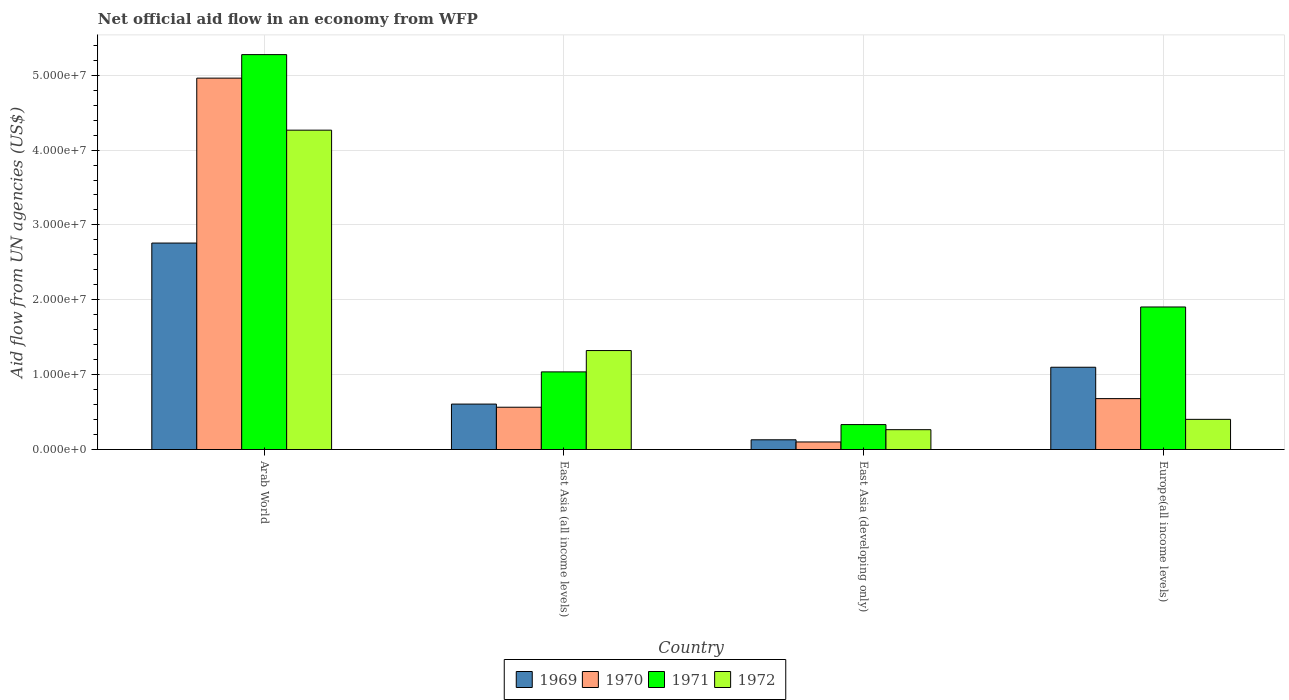How many bars are there on the 1st tick from the left?
Your answer should be compact. 4. What is the label of the 1st group of bars from the left?
Provide a succinct answer. Arab World. What is the net official aid flow in 1971 in East Asia (all income levels)?
Give a very brief answer. 1.04e+07. Across all countries, what is the maximum net official aid flow in 1970?
Ensure brevity in your answer.  4.96e+07. Across all countries, what is the minimum net official aid flow in 1971?
Provide a short and direct response. 3.33e+06. In which country was the net official aid flow in 1971 maximum?
Keep it short and to the point. Arab World. In which country was the net official aid flow in 1970 minimum?
Keep it short and to the point. East Asia (developing only). What is the total net official aid flow in 1971 in the graph?
Your answer should be compact. 8.55e+07. What is the difference between the net official aid flow in 1970 in East Asia (all income levels) and that in East Asia (developing only)?
Give a very brief answer. 4.64e+06. What is the difference between the net official aid flow in 1970 in East Asia (all income levels) and the net official aid flow in 1969 in Europe(all income levels)?
Your answer should be very brief. -5.34e+06. What is the average net official aid flow in 1970 per country?
Your response must be concise. 1.58e+07. What is the difference between the net official aid flow of/in 1972 and net official aid flow of/in 1971 in Arab World?
Provide a short and direct response. -1.01e+07. In how many countries, is the net official aid flow in 1971 greater than 50000000 US$?
Offer a very short reply. 1. What is the ratio of the net official aid flow in 1972 in Arab World to that in Europe(all income levels)?
Keep it short and to the point. 10.59. What is the difference between the highest and the second highest net official aid flow in 1969?
Ensure brevity in your answer.  2.15e+07. What is the difference between the highest and the lowest net official aid flow in 1971?
Offer a terse response. 4.94e+07. In how many countries, is the net official aid flow in 1969 greater than the average net official aid flow in 1969 taken over all countries?
Provide a succinct answer. 1. Is it the case that in every country, the sum of the net official aid flow in 1971 and net official aid flow in 1972 is greater than the net official aid flow in 1969?
Ensure brevity in your answer.  Yes. How many bars are there?
Offer a very short reply. 16. How many countries are there in the graph?
Keep it short and to the point. 4. Are the values on the major ticks of Y-axis written in scientific E-notation?
Your answer should be very brief. Yes. Where does the legend appear in the graph?
Offer a very short reply. Bottom center. How are the legend labels stacked?
Make the answer very short. Horizontal. What is the title of the graph?
Offer a very short reply. Net official aid flow in an economy from WFP. What is the label or title of the Y-axis?
Your response must be concise. Aid flow from UN agencies (US$). What is the Aid flow from UN agencies (US$) of 1969 in Arab World?
Your response must be concise. 2.76e+07. What is the Aid flow from UN agencies (US$) of 1970 in Arab World?
Provide a short and direct response. 4.96e+07. What is the Aid flow from UN agencies (US$) of 1971 in Arab World?
Give a very brief answer. 5.28e+07. What is the Aid flow from UN agencies (US$) of 1972 in Arab World?
Ensure brevity in your answer.  4.27e+07. What is the Aid flow from UN agencies (US$) of 1969 in East Asia (all income levels)?
Provide a short and direct response. 6.07e+06. What is the Aid flow from UN agencies (US$) of 1970 in East Asia (all income levels)?
Your answer should be very brief. 5.65e+06. What is the Aid flow from UN agencies (US$) of 1971 in East Asia (all income levels)?
Offer a very short reply. 1.04e+07. What is the Aid flow from UN agencies (US$) in 1972 in East Asia (all income levels)?
Your answer should be compact. 1.32e+07. What is the Aid flow from UN agencies (US$) in 1969 in East Asia (developing only)?
Offer a terse response. 1.30e+06. What is the Aid flow from UN agencies (US$) of 1970 in East Asia (developing only)?
Give a very brief answer. 1.01e+06. What is the Aid flow from UN agencies (US$) in 1971 in East Asia (developing only)?
Provide a short and direct response. 3.33e+06. What is the Aid flow from UN agencies (US$) in 1972 in East Asia (developing only)?
Keep it short and to the point. 2.65e+06. What is the Aid flow from UN agencies (US$) in 1969 in Europe(all income levels)?
Make the answer very short. 1.10e+07. What is the Aid flow from UN agencies (US$) in 1970 in Europe(all income levels)?
Give a very brief answer. 6.80e+06. What is the Aid flow from UN agencies (US$) of 1971 in Europe(all income levels)?
Your answer should be compact. 1.90e+07. What is the Aid flow from UN agencies (US$) in 1972 in Europe(all income levels)?
Keep it short and to the point. 4.03e+06. Across all countries, what is the maximum Aid flow from UN agencies (US$) in 1969?
Your answer should be very brief. 2.76e+07. Across all countries, what is the maximum Aid flow from UN agencies (US$) of 1970?
Ensure brevity in your answer.  4.96e+07. Across all countries, what is the maximum Aid flow from UN agencies (US$) of 1971?
Offer a very short reply. 5.28e+07. Across all countries, what is the maximum Aid flow from UN agencies (US$) of 1972?
Ensure brevity in your answer.  4.27e+07. Across all countries, what is the minimum Aid flow from UN agencies (US$) in 1969?
Provide a short and direct response. 1.30e+06. Across all countries, what is the minimum Aid flow from UN agencies (US$) in 1970?
Make the answer very short. 1.01e+06. Across all countries, what is the minimum Aid flow from UN agencies (US$) in 1971?
Your answer should be compact. 3.33e+06. Across all countries, what is the minimum Aid flow from UN agencies (US$) in 1972?
Make the answer very short. 2.65e+06. What is the total Aid flow from UN agencies (US$) of 1969 in the graph?
Offer a terse response. 4.59e+07. What is the total Aid flow from UN agencies (US$) of 1970 in the graph?
Offer a very short reply. 6.31e+07. What is the total Aid flow from UN agencies (US$) in 1971 in the graph?
Make the answer very short. 8.55e+07. What is the total Aid flow from UN agencies (US$) in 1972 in the graph?
Ensure brevity in your answer.  6.26e+07. What is the difference between the Aid flow from UN agencies (US$) of 1969 in Arab World and that in East Asia (all income levels)?
Ensure brevity in your answer.  2.15e+07. What is the difference between the Aid flow from UN agencies (US$) in 1970 in Arab World and that in East Asia (all income levels)?
Your response must be concise. 4.40e+07. What is the difference between the Aid flow from UN agencies (US$) in 1971 in Arab World and that in East Asia (all income levels)?
Offer a terse response. 4.24e+07. What is the difference between the Aid flow from UN agencies (US$) of 1972 in Arab World and that in East Asia (all income levels)?
Offer a very short reply. 2.94e+07. What is the difference between the Aid flow from UN agencies (US$) of 1969 in Arab World and that in East Asia (developing only)?
Offer a very short reply. 2.63e+07. What is the difference between the Aid flow from UN agencies (US$) in 1970 in Arab World and that in East Asia (developing only)?
Your answer should be compact. 4.86e+07. What is the difference between the Aid flow from UN agencies (US$) of 1971 in Arab World and that in East Asia (developing only)?
Give a very brief answer. 4.94e+07. What is the difference between the Aid flow from UN agencies (US$) in 1972 in Arab World and that in East Asia (developing only)?
Your answer should be very brief. 4.00e+07. What is the difference between the Aid flow from UN agencies (US$) in 1969 in Arab World and that in Europe(all income levels)?
Your response must be concise. 1.66e+07. What is the difference between the Aid flow from UN agencies (US$) of 1970 in Arab World and that in Europe(all income levels)?
Offer a very short reply. 4.28e+07. What is the difference between the Aid flow from UN agencies (US$) of 1971 in Arab World and that in Europe(all income levels)?
Your response must be concise. 3.37e+07. What is the difference between the Aid flow from UN agencies (US$) of 1972 in Arab World and that in Europe(all income levels)?
Your answer should be compact. 3.86e+07. What is the difference between the Aid flow from UN agencies (US$) in 1969 in East Asia (all income levels) and that in East Asia (developing only)?
Make the answer very short. 4.77e+06. What is the difference between the Aid flow from UN agencies (US$) of 1970 in East Asia (all income levels) and that in East Asia (developing only)?
Give a very brief answer. 4.64e+06. What is the difference between the Aid flow from UN agencies (US$) in 1971 in East Asia (all income levels) and that in East Asia (developing only)?
Keep it short and to the point. 7.04e+06. What is the difference between the Aid flow from UN agencies (US$) of 1972 in East Asia (all income levels) and that in East Asia (developing only)?
Provide a succinct answer. 1.06e+07. What is the difference between the Aid flow from UN agencies (US$) in 1969 in East Asia (all income levels) and that in Europe(all income levels)?
Your response must be concise. -4.92e+06. What is the difference between the Aid flow from UN agencies (US$) of 1970 in East Asia (all income levels) and that in Europe(all income levels)?
Offer a very short reply. -1.15e+06. What is the difference between the Aid flow from UN agencies (US$) of 1971 in East Asia (all income levels) and that in Europe(all income levels)?
Provide a short and direct response. -8.67e+06. What is the difference between the Aid flow from UN agencies (US$) in 1972 in East Asia (all income levels) and that in Europe(all income levels)?
Give a very brief answer. 9.19e+06. What is the difference between the Aid flow from UN agencies (US$) of 1969 in East Asia (developing only) and that in Europe(all income levels)?
Offer a very short reply. -9.69e+06. What is the difference between the Aid flow from UN agencies (US$) in 1970 in East Asia (developing only) and that in Europe(all income levels)?
Provide a succinct answer. -5.79e+06. What is the difference between the Aid flow from UN agencies (US$) in 1971 in East Asia (developing only) and that in Europe(all income levels)?
Provide a short and direct response. -1.57e+07. What is the difference between the Aid flow from UN agencies (US$) of 1972 in East Asia (developing only) and that in Europe(all income levels)?
Your answer should be very brief. -1.38e+06. What is the difference between the Aid flow from UN agencies (US$) of 1969 in Arab World and the Aid flow from UN agencies (US$) of 1970 in East Asia (all income levels)?
Keep it short and to the point. 2.19e+07. What is the difference between the Aid flow from UN agencies (US$) of 1969 in Arab World and the Aid flow from UN agencies (US$) of 1971 in East Asia (all income levels)?
Offer a very short reply. 1.72e+07. What is the difference between the Aid flow from UN agencies (US$) of 1969 in Arab World and the Aid flow from UN agencies (US$) of 1972 in East Asia (all income levels)?
Provide a succinct answer. 1.44e+07. What is the difference between the Aid flow from UN agencies (US$) of 1970 in Arab World and the Aid flow from UN agencies (US$) of 1971 in East Asia (all income levels)?
Your answer should be compact. 3.92e+07. What is the difference between the Aid flow from UN agencies (US$) in 1970 in Arab World and the Aid flow from UN agencies (US$) in 1972 in East Asia (all income levels)?
Keep it short and to the point. 3.64e+07. What is the difference between the Aid flow from UN agencies (US$) in 1971 in Arab World and the Aid flow from UN agencies (US$) in 1972 in East Asia (all income levels)?
Ensure brevity in your answer.  3.95e+07. What is the difference between the Aid flow from UN agencies (US$) in 1969 in Arab World and the Aid flow from UN agencies (US$) in 1970 in East Asia (developing only)?
Make the answer very short. 2.66e+07. What is the difference between the Aid flow from UN agencies (US$) in 1969 in Arab World and the Aid flow from UN agencies (US$) in 1971 in East Asia (developing only)?
Your response must be concise. 2.42e+07. What is the difference between the Aid flow from UN agencies (US$) in 1969 in Arab World and the Aid flow from UN agencies (US$) in 1972 in East Asia (developing only)?
Ensure brevity in your answer.  2.49e+07. What is the difference between the Aid flow from UN agencies (US$) in 1970 in Arab World and the Aid flow from UN agencies (US$) in 1971 in East Asia (developing only)?
Offer a very short reply. 4.63e+07. What is the difference between the Aid flow from UN agencies (US$) of 1970 in Arab World and the Aid flow from UN agencies (US$) of 1972 in East Asia (developing only)?
Ensure brevity in your answer.  4.70e+07. What is the difference between the Aid flow from UN agencies (US$) of 1971 in Arab World and the Aid flow from UN agencies (US$) of 1972 in East Asia (developing only)?
Offer a very short reply. 5.01e+07. What is the difference between the Aid flow from UN agencies (US$) in 1969 in Arab World and the Aid flow from UN agencies (US$) in 1970 in Europe(all income levels)?
Keep it short and to the point. 2.08e+07. What is the difference between the Aid flow from UN agencies (US$) in 1969 in Arab World and the Aid flow from UN agencies (US$) in 1971 in Europe(all income levels)?
Make the answer very short. 8.54e+06. What is the difference between the Aid flow from UN agencies (US$) in 1969 in Arab World and the Aid flow from UN agencies (US$) in 1972 in Europe(all income levels)?
Provide a short and direct response. 2.36e+07. What is the difference between the Aid flow from UN agencies (US$) of 1970 in Arab World and the Aid flow from UN agencies (US$) of 1971 in Europe(all income levels)?
Provide a succinct answer. 3.06e+07. What is the difference between the Aid flow from UN agencies (US$) of 1970 in Arab World and the Aid flow from UN agencies (US$) of 1972 in Europe(all income levels)?
Make the answer very short. 4.56e+07. What is the difference between the Aid flow from UN agencies (US$) of 1971 in Arab World and the Aid flow from UN agencies (US$) of 1972 in Europe(all income levels)?
Keep it short and to the point. 4.87e+07. What is the difference between the Aid flow from UN agencies (US$) in 1969 in East Asia (all income levels) and the Aid flow from UN agencies (US$) in 1970 in East Asia (developing only)?
Provide a succinct answer. 5.06e+06. What is the difference between the Aid flow from UN agencies (US$) of 1969 in East Asia (all income levels) and the Aid flow from UN agencies (US$) of 1971 in East Asia (developing only)?
Offer a terse response. 2.74e+06. What is the difference between the Aid flow from UN agencies (US$) of 1969 in East Asia (all income levels) and the Aid flow from UN agencies (US$) of 1972 in East Asia (developing only)?
Keep it short and to the point. 3.42e+06. What is the difference between the Aid flow from UN agencies (US$) of 1970 in East Asia (all income levels) and the Aid flow from UN agencies (US$) of 1971 in East Asia (developing only)?
Provide a succinct answer. 2.32e+06. What is the difference between the Aid flow from UN agencies (US$) of 1970 in East Asia (all income levels) and the Aid flow from UN agencies (US$) of 1972 in East Asia (developing only)?
Give a very brief answer. 3.00e+06. What is the difference between the Aid flow from UN agencies (US$) in 1971 in East Asia (all income levels) and the Aid flow from UN agencies (US$) in 1972 in East Asia (developing only)?
Your answer should be compact. 7.72e+06. What is the difference between the Aid flow from UN agencies (US$) in 1969 in East Asia (all income levels) and the Aid flow from UN agencies (US$) in 1970 in Europe(all income levels)?
Your response must be concise. -7.30e+05. What is the difference between the Aid flow from UN agencies (US$) of 1969 in East Asia (all income levels) and the Aid flow from UN agencies (US$) of 1971 in Europe(all income levels)?
Provide a short and direct response. -1.30e+07. What is the difference between the Aid flow from UN agencies (US$) of 1969 in East Asia (all income levels) and the Aid flow from UN agencies (US$) of 1972 in Europe(all income levels)?
Offer a very short reply. 2.04e+06. What is the difference between the Aid flow from UN agencies (US$) of 1970 in East Asia (all income levels) and the Aid flow from UN agencies (US$) of 1971 in Europe(all income levels)?
Make the answer very short. -1.34e+07. What is the difference between the Aid flow from UN agencies (US$) in 1970 in East Asia (all income levels) and the Aid flow from UN agencies (US$) in 1972 in Europe(all income levels)?
Your answer should be compact. 1.62e+06. What is the difference between the Aid flow from UN agencies (US$) in 1971 in East Asia (all income levels) and the Aid flow from UN agencies (US$) in 1972 in Europe(all income levels)?
Provide a short and direct response. 6.34e+06. What is the difference between the Aid flow from UN agencies (US$) in 1969 in East Asia (developing only) and the Aid flow from UN agencies (US$) in 1970 in Europe(all income levels)?
Ensure brevity in your answer.  -5.50e+06. What is the difference between the Aid flow from UN agencies (US$) of 1969 in East Asia (developing only) and the Aid flow from UN agencies (US$) of 1971 in Europe(all income levels)?
Give a very brief answer. -1.77e+07. What is the difference between the Aid flow from UN agencies (US$) in 1969 in East Asia (developing only) and the Aid flow from UN agencies (US$) in 1972 in Europe(all income levels)?
Ensure brevity in your answer.  -2.73e+06. What is the difference between the Aid flow from UN agencies (US$) of 1970 in East Asia (developing only) and the Aid flow from UN agencies (US$) of 1971 in Europe(all income levels)?
Keep it short and to the point. -1.80e+07. What is the difference between the Aid flow from UN agencies (US$) of 1970 in East Asia (developing only) and the Aid flow from UN agencies (US$) of 1972 in Europe(all income levels)?
Offer a terse response. -3.02e+06. What is the difference between the Aid flow from UN agencies (US$) in 1971 in East Asia (developing only) and the Aid flow from UN agencies (US$) in 1972 in Europe(all income levels)?
Give a very brief answer. -7.00e+05. What is the average Aid flow from UN agencies (US$) in 1969 per country?
Keep it short and to the point. 1.15e+07. What is the average Aid flow from UN agencies (US$) in 1970 per country?
Offer a terse response. 1.58e+07. What is the average Aid flow from UN agencies (US$) of 1971 per country?
Offer a terse response. 2.14e+07. What is the average Aid flow from UN agencies (US$) of 1972 per country?
Ensure brevity in your answer.  1.56e+07. What is the difference between the Aid flow from UN agencies (US$) in 1969 and Aid flow from UN agencies (US$) in 1970 in Arab World?
Offer a very short reply. -2.20e+07. What is the difference between the Aid flow from UN agencies (US$) in 1969 and Aid flow from UN agencies (US$) in 1971 in Arab World?
Provide a succinct answer. -2.52e+07. What is the difference between the Aid flow from UN agencies (US$) in 1969 and Aid flow from UN agencies (US$) in 1972 in Arab World?
Your response must be concise. -1.51e+07. What is the difference between the Aid flow from UN agencies (US$) of 1970 and Aid flow from UN agencies (US$) of 1971 in Arab World?
Your answer should be compact. -3.14e+06. What is the difference between the Aid flow from UN agencies (US$) of 1970 and Aid flow from UN agencies (US$) of 1972 in Arab World?
Keep it short and to the point. 6.95e+06. What is the difference between the Aid flow from UN agencies (US$) of 1971 and Aid flow from UN agencies (US$) of 1972 in Arab World?
Provide a succinct answer. 1.01e+07. What is the difference between the Aid flow from UN agencies (US$) of 1969 and Aid flow from UN agencies (US$) of 1971 in East Asia (all income levels)?
Ensure brevity in your answer.  -4.30e+06. What is the difference between the Aid flow from UN agencies (US$) in 1969 and Aid flow from UN agencies (US$) in 1972 in East Asia (all income levels)?
Give a very brief answer. -7.15e+06. What is the difference between the Aid flow from UN agencies (US$) in 1970 and Aid flow from UN agencies (US$) in 1971 in East Asia (all income levels)?
Your answer should be very brief. -4.72e+06. What is the difference between the Aid flow from UN agencies (US$) of 1970 and Aid flow from UN agencies (US$) of 1972 in East Asia (all income levels)?
Your answer should be compact. -7.57e+06. What is the difference between the Aid flow from UN agencies (US$) of 1971 and Aid flow from UN agencies (US$) of 1972 in East Asia (all income levels)?
Keep it short and to the point. -2.85e+06. What is the difference between the Aid flow from UN agencies (US$) of 1969 and Aid flow from UN agencies (US$) of 1971 in East Asia (developing only)?
Your response must be concise. -2.03e+06. What is the difference between the Aid flow from UN agencies (US$) of 1969 and Aid flow from UN agencies (US$) of 1972 in East Asia (developing only)?
Provide a succinct answer. -1.35e+06. What is the difference between the Aid flow from UN agencies (US$) in 1970 and Aid flow from UN agencies (US$) in 1971 in East Asia (developing only)?
Provide a short and direct response. -2.32e+06. What is the difference between the Aid flow from UN agencies (US$) in 1970 and Aid flow from UN agencies (US$) in 1972 in East Asia (developing only)?
Ensure brevity in your answer.  -1.64e+06. What is the difference between the Aid flow from UN agencies (US$) of 1971 and Aid flow from UN agencies (US$) of 1972 in East Asia (developing only)?
Your response must be concise. 6.80e+05. What is the difference between the Aid flow from UN agencies (US$) in 1969 and Aid flow from UN agencies (US$) in 1970 in Europe(all income levels)?
Give a very brief answer. 4.19e+06. What is the difference between the Aid flow from UN agencies (US$) in 1969 and Aid flow from UN agencies (US$) in 1971 in Europe(all income levels)?
Offer a terse response. -8.05e+06. What is the difference between the Aid flow from UN agencies (US$) in 1969 and Aid flow from UN agencies (US$) in 1972 in Europe(all income levels)?
Offer a very short reply. 6.96e+06. What is the difference between the Aid flow from UN agencies (US$) in 1970 and Aid flow from UN agencies (US$) in 1971 in Europe(all income levels)?
Provide a short and direct response. -1.22e+07. What is the difference between the Aid flow from UN agencies (US$) in 1970 and Aid flow from UN agencies (US$) in 1972 in Europe(all income levels)?
Provide a short and direct response. 2.77e+06. What is the difference between the Aid flow from UN agencies (US$) of 1971 and Aid flow from UN agencies (US$) of 1972 in Europe(all income levels)?
Offer a very short reply. 1.50e+07. What is the ratio of the Aid flow from UN agencies (US$) of 1969 in Arab World to that in East Asia (all income levels)?
Your answer should be compact. 4.54. What is the ratio of the Aid flow from UN agencies (US$) in 1970 in Arab World to that in East Asia (all income levels)?
Give a very brief answer. 8.78. What is the ratio of the Aid flow from UN agencies (US$) of 1971 in Arab World to that in East Asia (all income levels)?
Your answer should be compact. 5.09. What is the ratio of the Aid flow from UN agencies (US$) of 1972 in Arab World to that in East Asia (all income levels)?
Your response must be concise. 3.23. What is the ratio of the Aid flow from UN agencies (US$) in 1969 in Arab World to that in East Asia (developing only)?
Keep it short and to the point. 21.22. What is the ratio of the Aid flow from UN agencies (US$) in 1970 in Arab World to that in East Asia (developing only)?
Your answer should be very brief. 49.12. What is the ratio of the Aid flow from UN agencies (US$) of 1971 in Arab World to that in East Asia (developing only)?
Keep it short and to the point. 15.84. What is the ratio of the Aid flow from UN agencies (US$) in 1972 in Arab World to that in East Asia (developing only)?
Offer a very short reply. 16.1. What is the ratio of the Aid flow from UN agencies (US$) in 1969 in Arab World to that in Europe(all income levels)?
Provide a succinct answer. 2.51. What is the ratio of the Aid flow from UN agencies (US$) in 1970 in Arab World to that in Europe(all income levels)?
Offer a terse response. 7.3. What is the ratio of the Aid flow from UN agencies (US$) of 1971 in Arab World to that in Europe(all income levels)?
Offer a very short reply. 2.77. What is the ratio of the Aid flow from UN agencies (US$) of 1972 in Arab World to that in Europe(all income levels)?
Keep it short and to the point. 10.59. What is the ratio of the Aid flow from UN agencies (US$) in 1969 in East Asia (all income levels) to that in East Asia (developing only)?
Keep it short and to the point. 4.67. What is the ratio of the Aid flow from UN agencies (US$) in 1970 in East Asia (all income levels) to that in East Asia (developing only)?
Provide a short and direct response. 5.59. What is the ratio of the Aid flow from UN agencies (US$) of 1971 in East Asia (all income levels) to that in East Asia (developing only)?
Provide a succinct answer. 3.11. What is the ratio of the Aid flow from UN agencies (US$) of 1972 in East Asia (all income levels) to that in East Asia (developing only)?
Keep it short and to the point. 4.99. What is the ratio of the Aid flow from UN agencies (US$) in 1969 in East Asia (all income levels) to that in Europe(all income levels)?
Provide a short and direct response. 0.55. What is the ratio of the Aid flow from UN agencies (US$) of 1970 in East Asia (all income levels) to that in Europe(all income levels)?
Offer a terse response. 0.83. What is the ratio of the Aid flow from UN agencies (US$) in 1971 in East Asia (all income levels) to that in Europe(all income levels)?
Offer a very short reply. 0.54. What is the ratio of the Aid flow from UN agencies (US$) of 1972 in East Asia (all income levels) to that in Europe(all income levels)?
Keep it short and to the point. 3.28. What is the ratio of the Aid flow from UN agencies (US$) in 1969 in East Asia (developing only) to that in Europe(all income levels)?
Your response must be concise. 0.12. What is the ratio of the Aid flow from UN agencies (US$) of 1970 in East Asia (developing only) to that in Europe(all income levels)?
Provide a succinct answer. 0.15. What is the ratio of the Aid flow from UN agencies (US$) of 1971 in East Asia (developing only) to that in Europe(all income levels)?
Ensure brevity in your answer.  0.17. What is the ratio of the Aid flow from UN agencies (US$) in 1972 in East Asia (developing only) to that in Europe(all income levels)?
Provide a short and direct response. 0.66. What is the difference between the highest and the second highest Aid flow from UN agencies (US$) of 1969?
Your answer should be compact. 1.66e+07. What is the difference between the highest and the second highest Aid flow from UN agencies (US$) in 1970?
Give a very brief answer. 4.28e+07. What is the difference between the highest and the second highest Aid flow from UN agencies (US$) of 1971?
Make the answer very short. 3.37e+07. What is the difference between the highest and the second highest Aid flow from UN agencies (US$) in 1972?
Give a very brief answer. 2.94e+07. What is the difference between the highest and the lowest Aid flow from UN agencies (US$) of 1969?
Give a very brief answer. 2.63e+07. What is the difference between the highest and the lowest Aid flow from UN agencies (US$) in 1970?
Provide a succinct answer. 4.86e+07. What is the difference between the highest and the lowest Aid flow from UN agencies (US$) in 1971?
Offer a terse response. 4.94e+07. What is the difference between the highest and the lowest Aid flow from UN agencies (US$) of 1972?
Make the answer very short. 4.00e+07. 